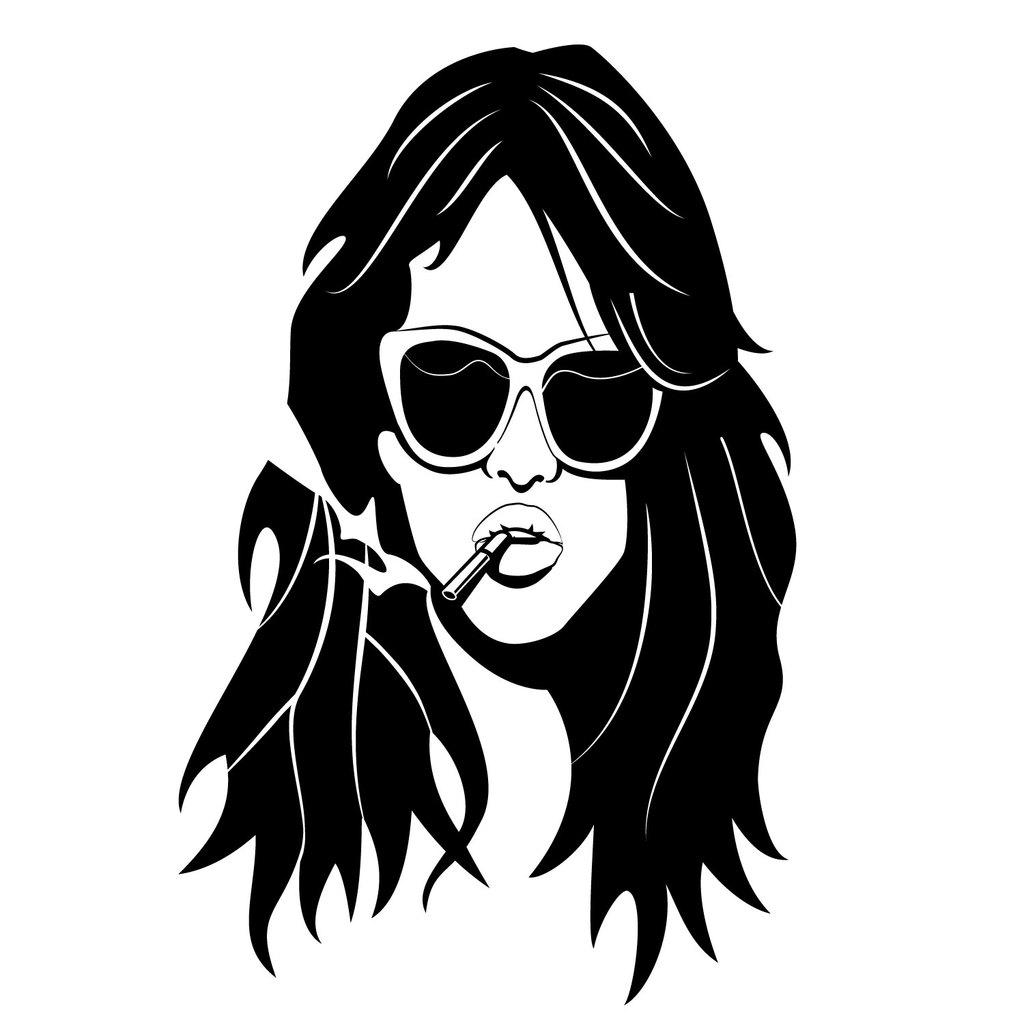What is the main subject of the image? There is an art piece in the middle of the image. What type of clam can be seen in the aftermath of the sun in the image? There is no clam or reference to the sun in the image; it only features an art piece. 